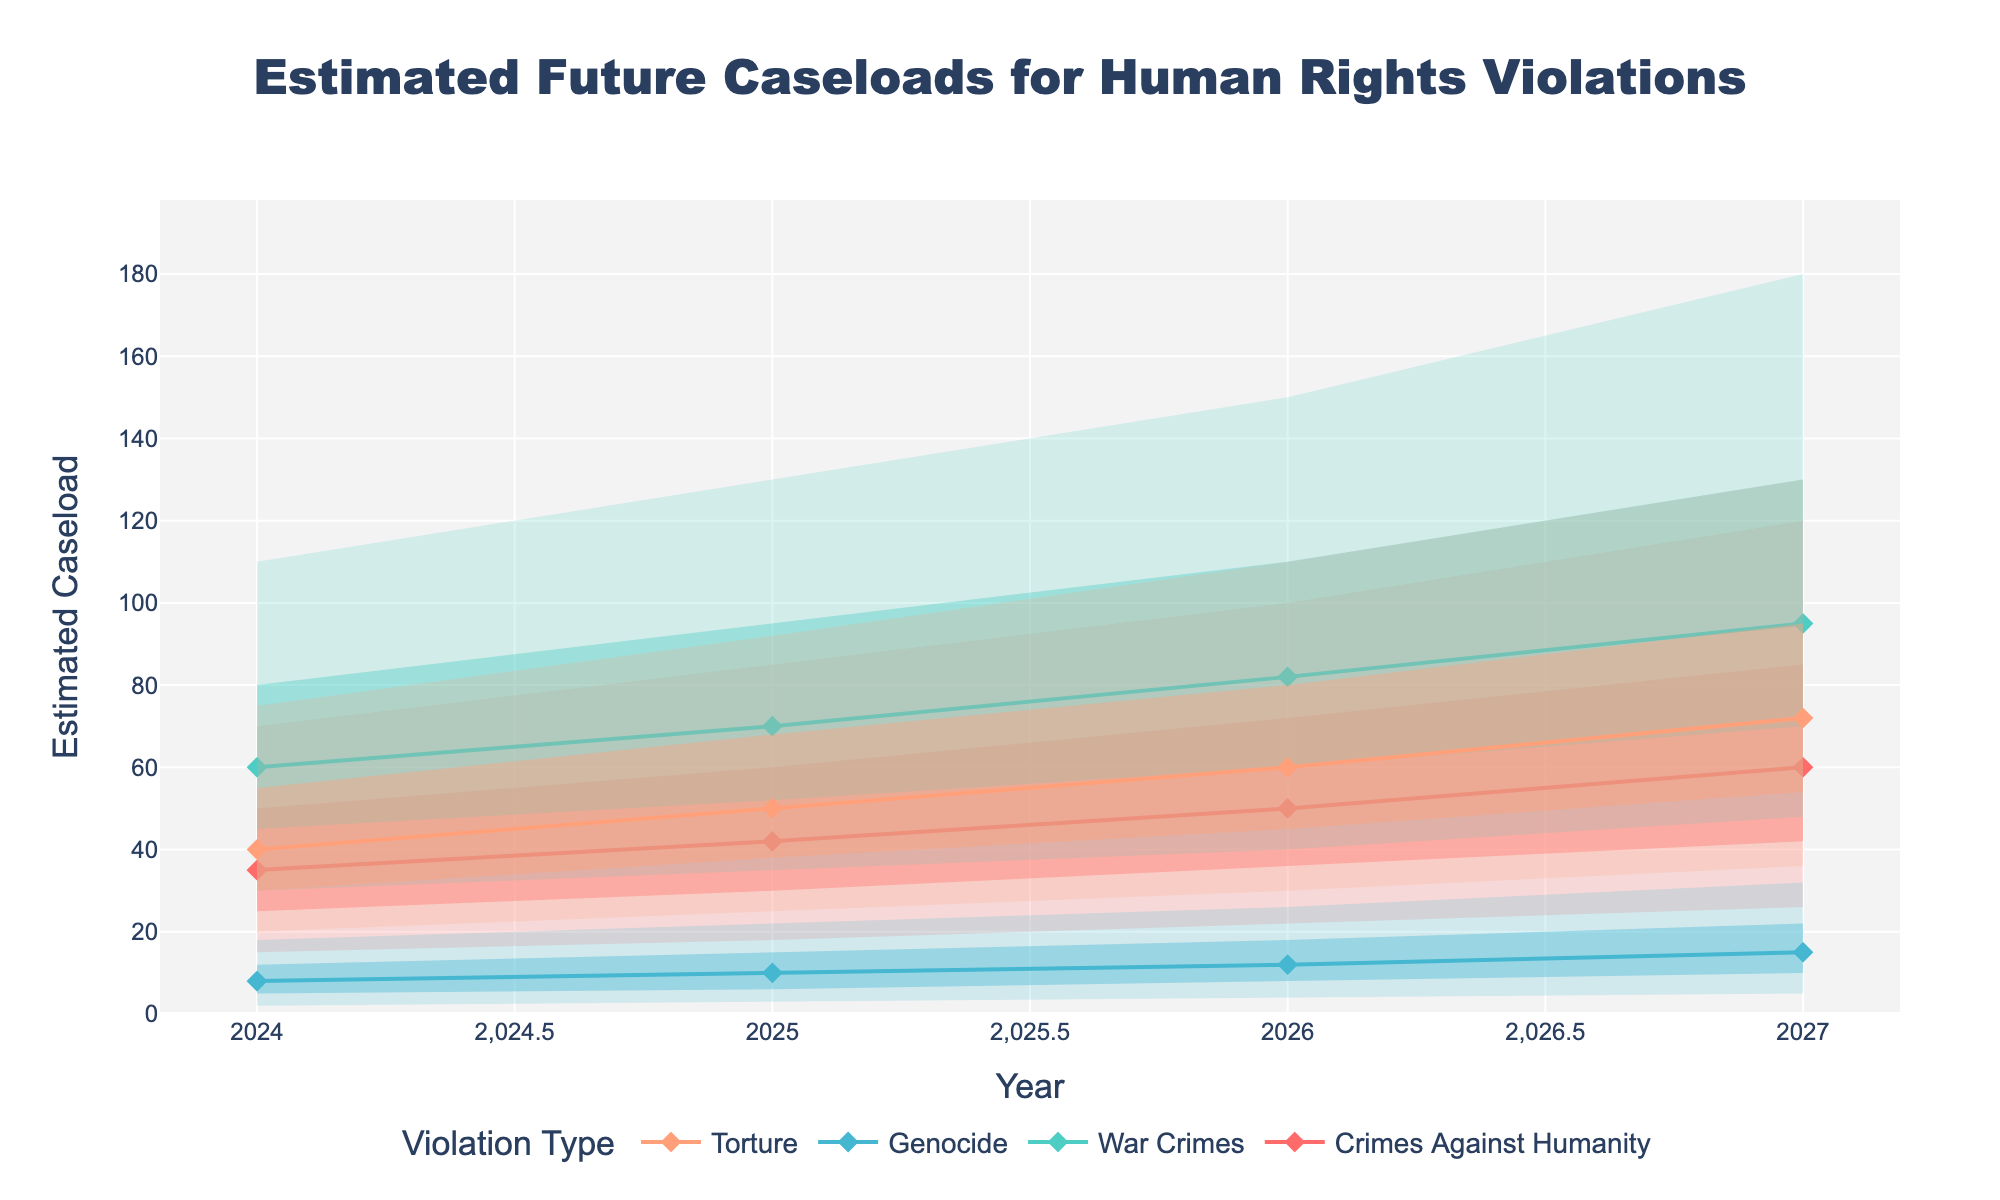What's the title of the figure? The title is displayed at the top of the figure. It provides an overview of what the figure is about. In this case, the title is "Estimated Future Caseloads for Human Rights Violations."
Answer: Estimated Future Caseloads for Human Rights Violations What does the x-axis represent? The x-axis, labeled "Year," indicates the years from 2024 to 2027, showing the time period over which the estimated caseloads are predicted.
Answer: Year What does the y-axis represent? The y-axis is labeled "Estimated Caseload," displaying the number of cases projected for different types of human rights violations in international courts.
Answer: Estimated Caseload What is the median estimated caseload for War Crimes in 2024? The median value for War Crimes in 2024 can be directly read from the plot’s series for War Crimes. The median value is marked with a line and symbols for each violation type. For 2024, the value is 60.
Answer: 60 What type of human rights violation is expected to have the highest median caseload in 2026? By comparing the median lines for each violation type in 2026, War Crimes has the highest median, which is 82.
Answer: War Crimes Which year shows the highest 95th percentile estimate for Genocide cases? The highest 95th percentile number for Genocide across the years is observed by looking at the top boundary of the gray-shaded region for Genocide. The highest value is in 2027, which is 32.
Answer: 2027 What is the range of estimated caseloads for Torture in 2025, from the 5th to the 95th percentile? The range is calculated by subtracting the 5th percentile value (25) from the 95th percentile value (92) for Torture in 2025. So, 92 - 25 = 67.
Answer: 67 Between 2024 and 2027, how much does the median estimate for Crimes Against Humanity increase? The median for Crimes Against Humanity in 2024 is 35, and in 2027 it's 60. The increase is calculated as 60 - 35 = 25.
Answer: 25 Which violation type has the most significant difference between the 5th and 95th percentiles in 2027? By comparing the difference between the 5th and 95th percentiles for all violation types in 2027, War Crimes has the largest difference which is 180 - 48 = 132.
Answer: War Crimes Based on the plot, how does the uncertainty (range between 5th and 95th percentiles) for Torture change from 2024 to 2027? The 5th percentile for Torture in 2024 is 20 and the 95th percentile is 75, giving a range of 75 - 20 = 55. In 2027, the 5th percentile is 36 and the 95th percentile is 130, giving a range of 130 - 36 = 94. The range increases from 55 to 94, indicating the uncertainty in the caseload estimate has increased over time.
Answer: Increased 